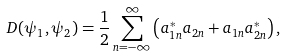Convert formula to latex. <formula><loc_0><loc_0><loc_500><loc_500>\ D ( \psi _ { 1 } , \psi _ { 2 } ) = \frac { 1 } { 2 } \sum _ { n = - \infty } ^ { \infty } \left ( a _ { 1 n } ^ { * } a _ { 2 n } + a _ { 1 n } a _ { 2 n } ^ { * } \right ) ,</formula> 